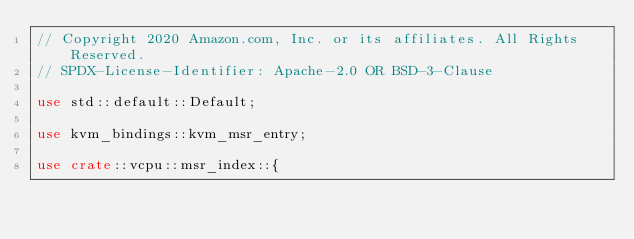<code> <loc_0><loc_0><loc_500><loc_500><_Rust_>// Copyright 2020 Amazon.com, Inc. or its affiliates. All Rights Reserved.
// SPDX-License-Identifier: Apache-2.0 OR BSD-3-Clause

use std::default::Default;

use kvm_bindings::kvm_msr_entry;

use crate::vcpu::msr_index::{</code> 